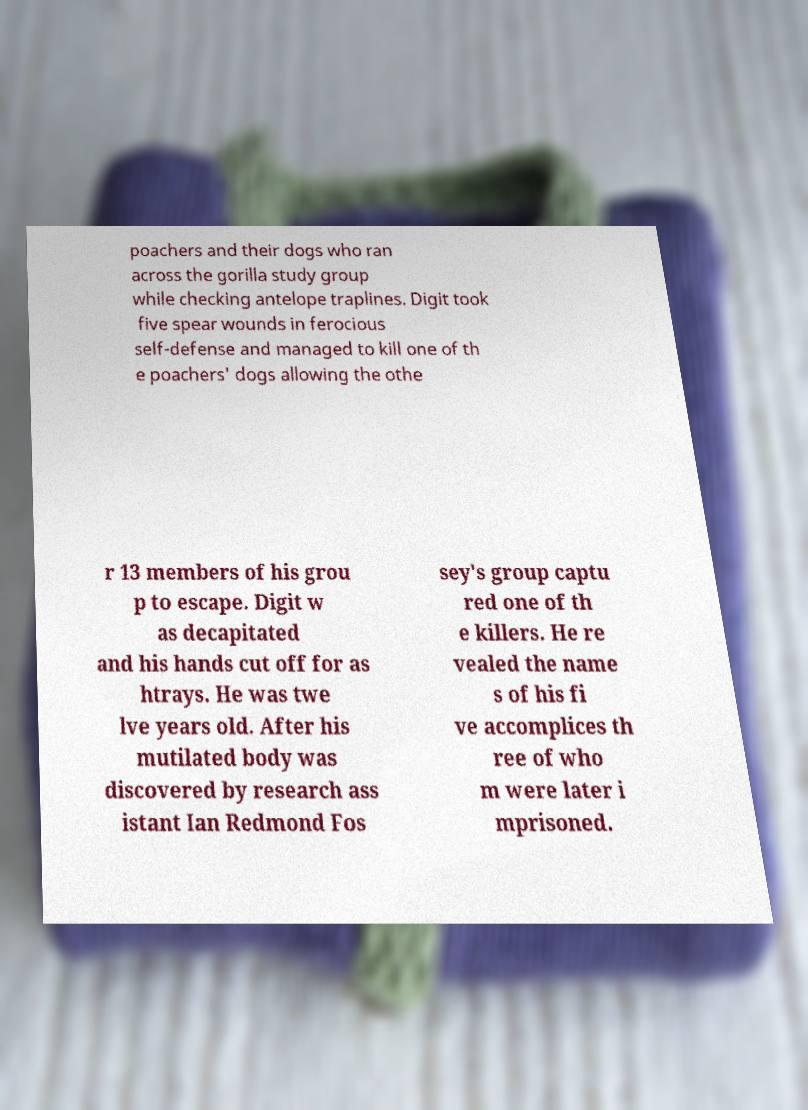Could you extract and type out the text from this image? poachers and their dogs who ran across the gorilla study group while checking antelope traplines. Digit took five spear wounds in ferocious self-defense and managed to kill one of th e poachers' dogs allowing the othe r 13 members of his grou p to escape. Digit w as decapitated and his hands cut off for as htrays. He was twe lve years old. After his mutilated body was discovered by research ass istant Ian Redmond Fos sey's group captu red one of th e killers. He re vealed the name s of his fi ve accomplices th ree of who m were later i mprisoned. 